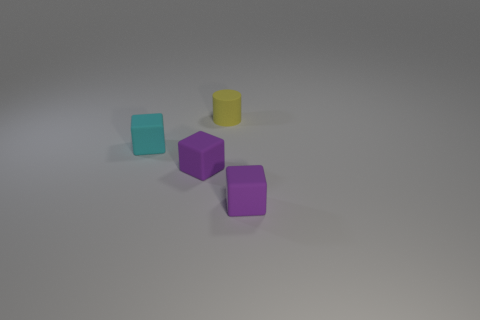What number of objects are matte blocks on the right side of the tiny matte cylinder or rubber objects that are behind the tiny cyan matte block?
Your answer should be very brief. 2. Is the number of small rubber objects less than the number of cyan metal spheres?
Your response must be concise. No. What is the shape of the cyan object that is the same size as the yellow rubber cylinder?
Make the answer very short. Cube. What number of other things are the same color as the small cylinder?
Keep it short and to the point. 0. What number of purple objects are there?
Provide a short and direct response. 2. How many matte objects are both right of the matte cylinder and on the left side of the yellow cylinder?
Offer a very short reply. 0. What is the material of the yellow cylinder?
Provide a short and direct response. Rubber. Is there a shiny object?
Your answer should be compact. No. The tiny rubber thing on the right side of the tiny matte cylinder is what color?
Keep it short and to the point. Purple. What number of tiny purple blocks are behind the small matte block on the right side of the tiny thing behind the tiny cyan cube?
Give a very brief answer. 1. 